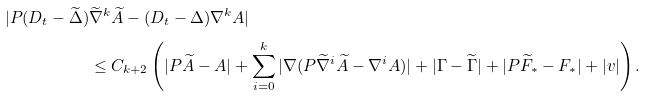<formula> <loc_0><loc_0><loc_500><loc_500>| P ( D _ { t } - \widetilde { \Delta } ) & \widetilde { \nabla } ^ { k } \widetilde { A } - ( D _ { t } - \Delta ) \nabla ^ { k } A | \\ & \leq C _ { k + 2 } \left ( | P \widetilde { A } - A | + \sum _ { i = 0 } ^ { k } | \nabla ( P \widetilde { \nabla } ^ { i } \widetilde { A } - \nabla ^ { i } A ) | + | \Gamma - \widetilde { \Gamma } | + | P \widetilde { F } _ { * } - F _ { * } | + | v | \right ) .</formula> 